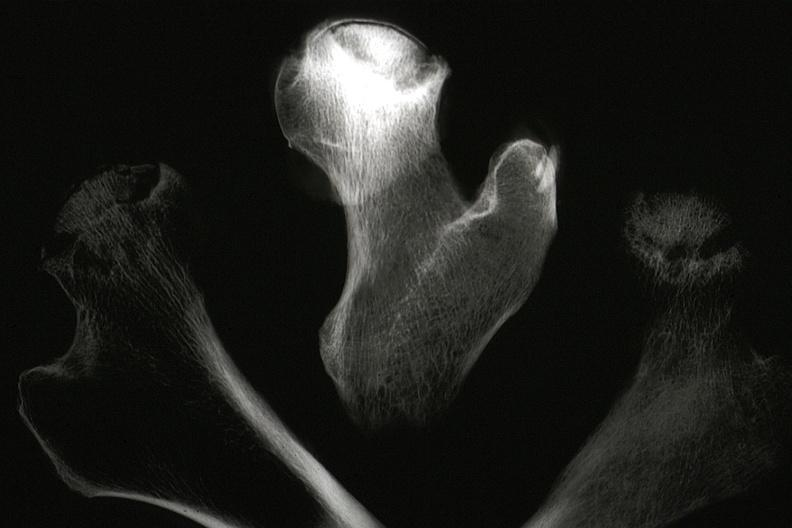what does this image show?
Answer the question using a single word or phrase. X-ray of sections of femur with femoral head necrosis seen in slide 